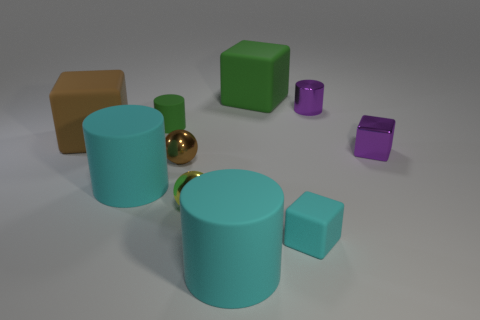Subtract all brown cubes. How many cyan cylinders are left? 2 Subtract all green cylinders. How many cylinders are left? 3 Subtract 2 cubes. How many cubes are left? 2 Subtract all green cylinders. How many cylinders are left? 3 Subtract all yellow cylinders. Subtract all cyan balls. How many cylinders are left? 4 Subtract all balls. How many objects are left? 8 Subtract 1 green cylinders. How many objects are left? 9 Subtract all large rubber cylinders. Subtract all purple metallic cylinders. How many objects are left? 7 Add 6 tiny brown metal things. How many tiny brown metal things are left? 7 Add 8 small gray matte balls. How many small gray matte balls exist? 8 